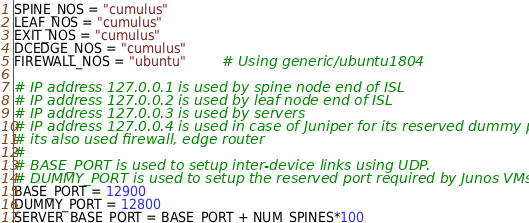Convert code to text. <code><loc_0><loc_0><loc_500><loc_500><_Ruby_>SPINE_NOS = "cumulus"
LEAF_NOS = "cumulus"
EXIT_NOS = "cumulus"
DCEDGE_NOS = "cumulus"
FIREWALL_NOS = "ubuntu"         # Using generic/ubuntu1804

# IP address 127.0.0.1 is used by spine node end of ISL
# IP address 127.0.0.2 is used by leaf node end of ISL
# IP address 127.0.0.3 is used by servers
# IP address 127.0.0.4 is used in case of Juniper for its reserved dummy port and
# its also used firewall, edge router
#
# BASE_PORT is used to setup inter-device links using UDP.
# DUMMY_PORT is used to setup the reserved port required by Junos VMs.
BASE_PORT = 12900
DUMMY_PORT = 12800
SERVER_BASE_PORT = BASE_PORT + NUM_SPINES*100
</code> 